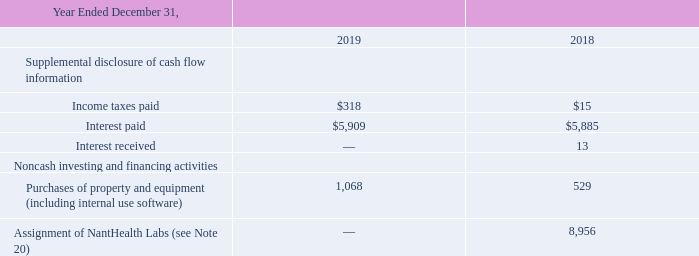NantHealth, Inc
Consolidated Statements of Cash Flows (Continued)
(Dollars in thousands)
(1) Cash and cash equivalents included restricted cash of $1,136, $1,136, and $350 at December 31, 2019, 2018, and 2017 included in other assets, respectively. Restricted cash consists of funds that are contractually restricted as to usage or withdrawal related to the Company's security deposits in the form of standby letters of credit for leased facilities. No amounts have been drawn upon the letters of credit as of December 31, 2019.
The accompanying notes are an integral part of these Consolidated Financial Statements.
What are the respective restricted cash included in the cash and cash equivalents in 2019 and 2017 respectively?
Answer scale should be: thousand. $1,136, $350. What are the respective restricted cash included in the cash and cash equivalents in 2018 and 2017 respectively?
Answer scale should be: thousand. $1,136, $350. What are the respective income taxes paid in 2018 and 2019?
Answer scale should be: thousand. $15, $318. What is the total income taxes paid in 2018 and 2019?
Answer scale should be: thousand. 15 + 318 
Answer: 333. What is the average interest paid by the company in 2018 and 2019?
Answer scale should be: thousand. (5,909 + 5,885)/2 
Answer: 5897. What is the percentage change in the interest paid between 2018 and 2019?
Answer scale should be: percent. (5,909 - 5,885)/5,885 
Answer: 0.41. 